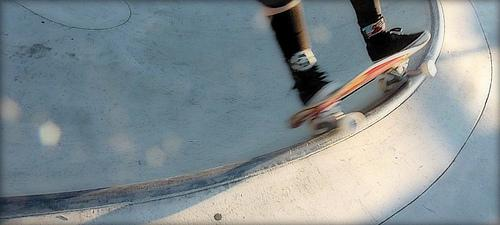Question: where is the picture taken?
Choices:
A. The lake house.
B. At a skatepark.
C. The school.
D. The waterfall.
Answer with the letter. Answer: B Question: what is the color of the shoe?
Choices:
A. Black and white.
B. Silver.
C. Red.
D. Black.
Answer with the letter. Answer: D Question: what is the man doing?
Choices:
A. Sawing a limb.
B. Driving a car.
C. Kissing a woman.
D. Skating.
Answer with the letter. Answer: D Question: how many skate boards?
Choices:
A. 3.
B. 4.
C. 5.
D. 1.
Answer with the letter. Answer: D Question: what is the color of the ground?
Choices:
A. Green.
B. Grey.
C. Brown.
D. White.
Answer with the letter. Answer: B 